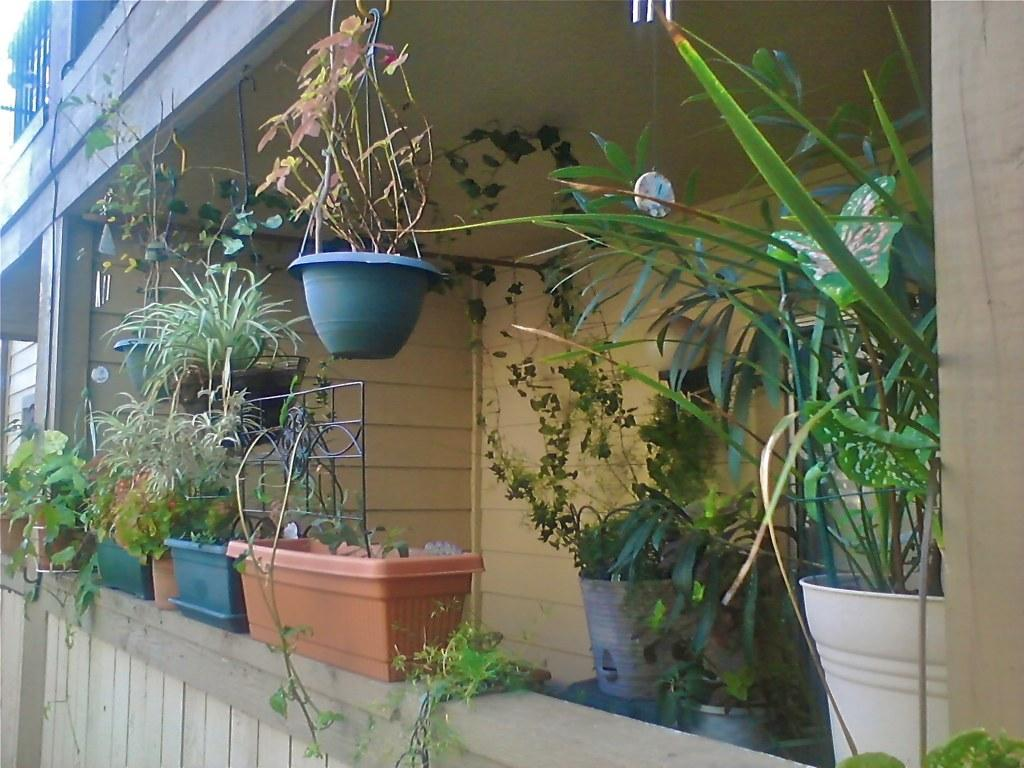What type of structure is visible in the image? There is a building in the image. What decorative elements can be seen on the wall of the building? There are house plants on the wall. What cooking appliances are present in the image? There are grills in the image. Can you describe any openings in the building? There is a window in the image. How many men are visible in the image? There are no men present in the image. What type of twig can be seen growing near the window? There is no twig visible in the image. 